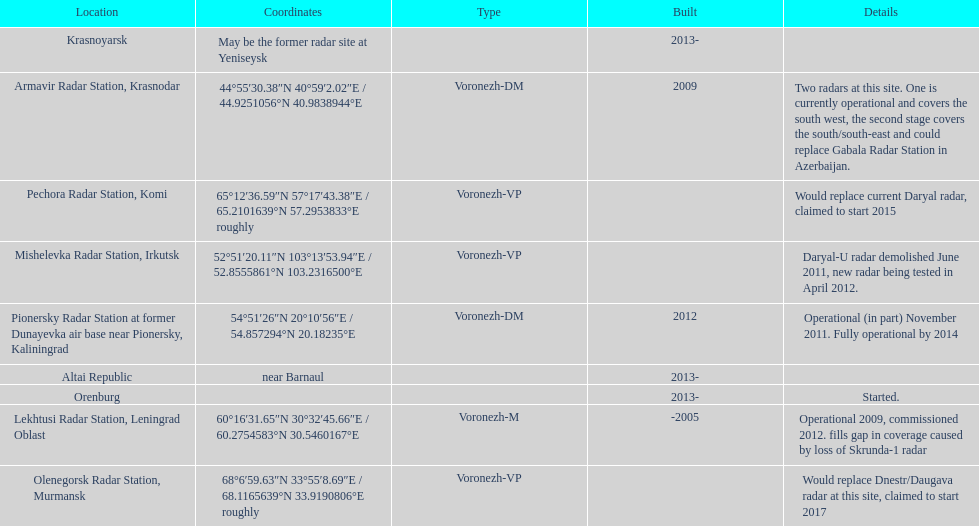How long did it take the pionersky radar station to go from partially operational to fully operational? 3 years. 